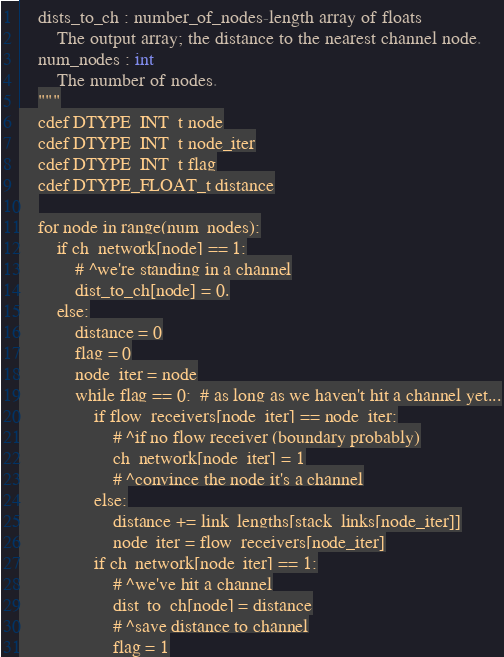Convert code to text. <code><loc_0><loc_0><loc_500><loc_500><_Cython_>    dists_to_ch : number_of_nodes-length array of floats
        The output array; the distance to the nearest channel node.
    num_nodes : int
        The number of nodes.
    """
    cdef DTYPE_INT_t node
    cdef DTYPE_INT_t node_iter
    cdef DTYPE_INT_t flag
    cdef DTYPE_FLOAT_t distance
    
    for node in range(num_nodes):
        if ch_network[node] == 1:
            # ^we're standing in a channel
            dist_to_ch[node] = 0.
        else:
            distance = 0
            flag = 0
            node_iter = node
            while flag == 0:  # as long as we haven't hit a channel yet...
                if flow_receivers[node_iter] == node_iter:
                    # ^if no flow receiver (boundary probably)
                    ch_network[node_iter] = 1
                    # ^convince the node it's a channel
                else:
                    distance += link_lengths[stack_links[node_iter]]
                    node_iter = flow_receivers[node_iter]
                if ch_network[node_iter] == 1:
                    # ^we've hit a channel
                    dist_to_ch[node] = distance
                    # ^save distance to channel
                    flag = 1
</code> 